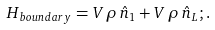Convert formula to latex. <formula><loc_0><loc_0><loc_500><loc_500>H _ { b o u n d a r y } = V \, \rho \, \hat { n } _ { 1 } + V \, \rho \, \hat { n } _ { L } ; .</formula> 